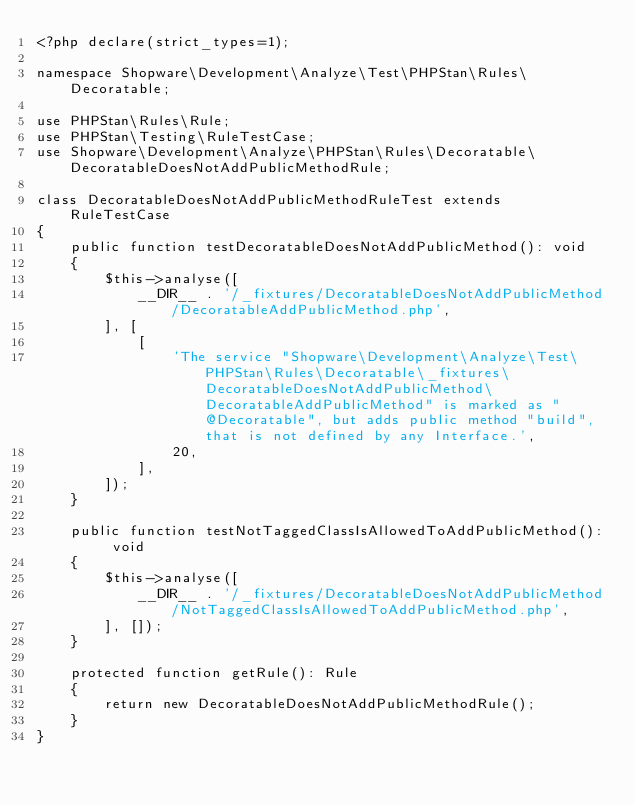Convert code to text. <code><loc_0><loc_0><loc_500><loc_500><_PHP_><?php declare(strict_types=1);

namespace Shopware\Development\Analyze\Test\PHPStan\Rules\Decoratable;

use PHPStan\Rules\Rule;
use PHPStan\Testing\RuleTestCase;
use Shopware\Development\Analyze\PHPStan\Rules\Decoratable\DecoratableDoesNotAddPublicMethodRule;

class DecoratableDoesNotAddPublicMethodRuleTest extends RuleTestCase
{
    public function testDecoratableDoesNotAddPublicMethod(): void
    {
        $this->analyse([
            __DIR__ . '/_fixtures/DecoratableDoesNotAddPublicMethod/DecoratableAddPublicMethod.php',
        ], [
            [
                'The service "Shopware\Development\Analyze\Test\PHPStan\Rules\Decoratable\_fixtures\DecoratableDoesNotAddPublicMethod\DecoratableAddPublicMethod" is marked as "@Decoratable", but adds public method "build", that is not defined by any Interface.',
                20,
            ],
        ]);
    }

    public function testNotTaggedClassIsAllowedToAddPublicMethod(): void
    {
        $this->analyse([
            __DIR__ . '/_fixtures/DecoratableDoesNotAddPublicMethod/NotTaggedClassIsAllowedToAddPublicMethod.php',
        ], []);
    }

    protected function getRule(): Rule
    {
        return new DecoratableDoesNotAddPublicMethodRule();
    }
}
</code> 